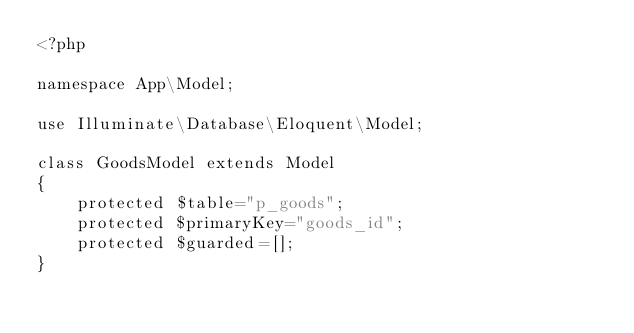Convert code to text. <code><loc_0><loc_0><loc_500><loc_500><_PHP_><?php

namespace App\Model;

use Illuminate\Database\Eloquent\Model;

class GoodsModel extends Model
{
    protected $table="p_goods";
    protected $primaryKey="goods_id";
    protected $guarded=[];
}
</code> 